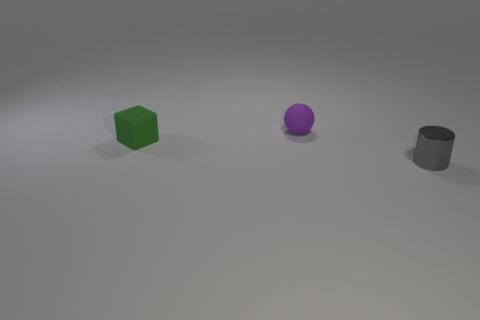Are there any other things that have the same material as the small cylinder?
Offer a very short reply. No. There is a purple object that is the same material as the green block; what is its shape?
Make the answer very short. Sphere. Are there any other things that have the same color as the cylinder?
Provide a succinct answer. No. Are there fewer tiny purple rubber objects to the left of the purple matte object than gray cylinders?
Offer a very short reply. Yes. What is the material of the tiny object in front of the tiny green rubber thing?
Offer a terse response. Metal. How many other things are there of the same size as the purple matte thing?
Keep it short and to the point. 2. What shape is the matte thing that is right of the rubber object that is left of the thing that is behind the green cube?
Offer a terse response. Sphere. Is the number of large red blocks less than the number of small purple balls?
Ensure brevity in your answer.  Yes. Are there any objects in front of the green cube?
Make the answer very short. Yes. The thing that is both to the right of the small matte block and on the left side of the small gray metallic cylinder has what shape?
Your response must be concise. Sphere. 